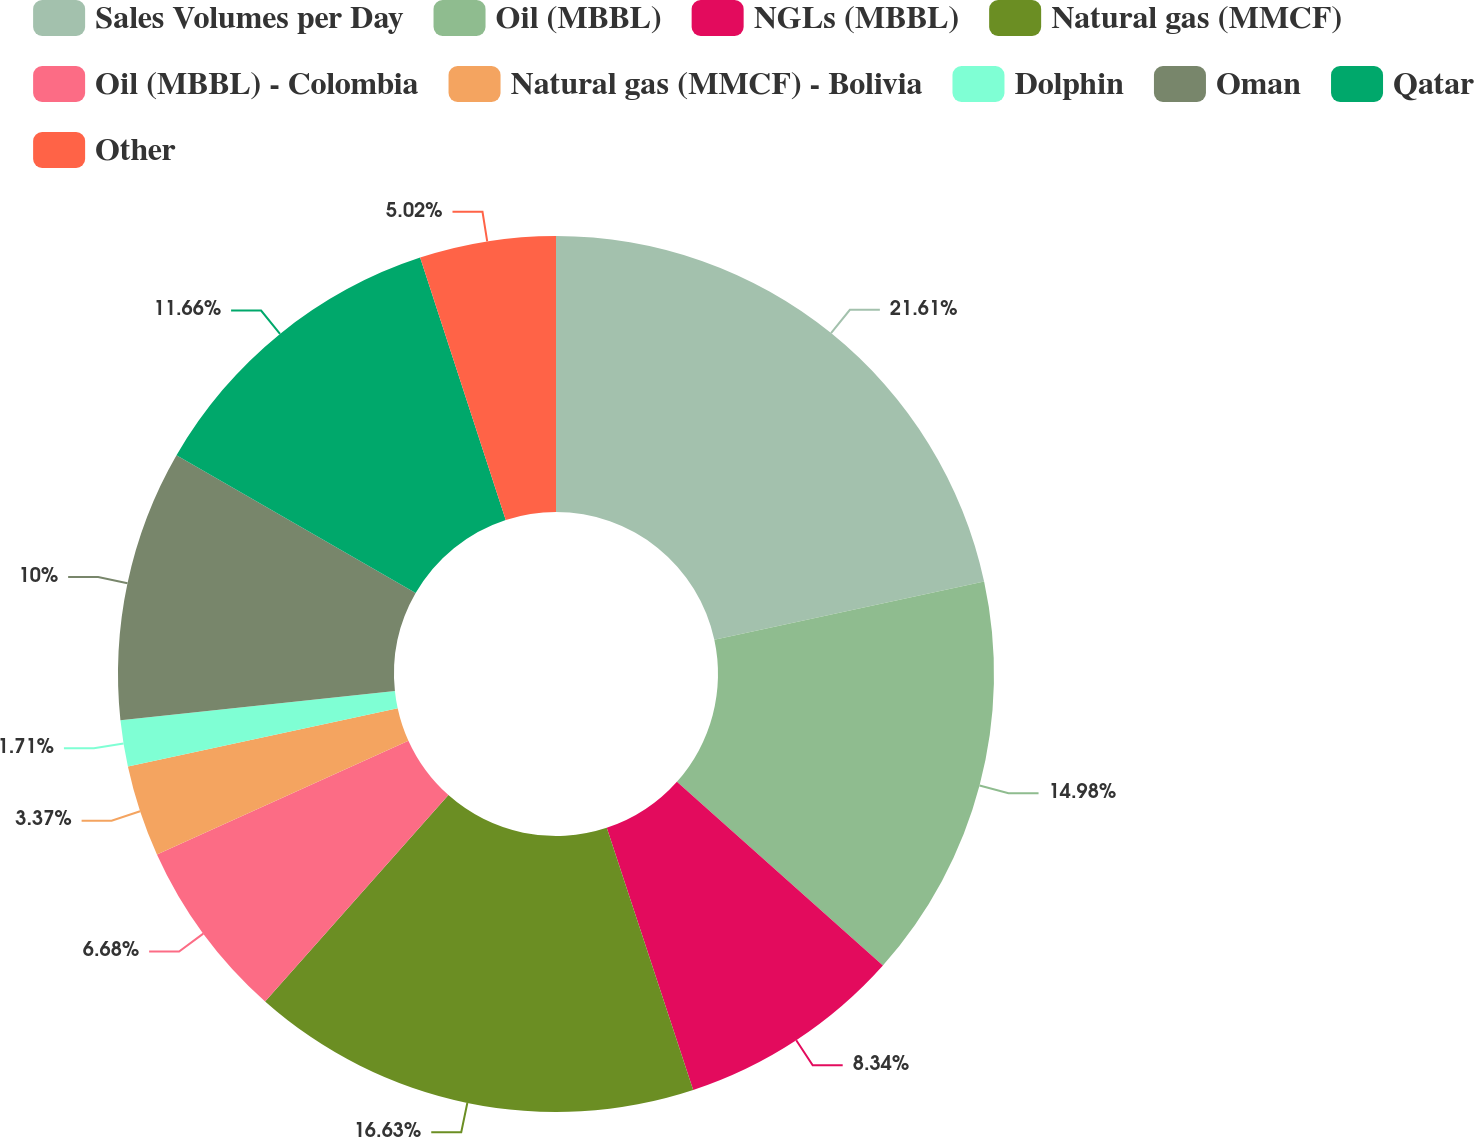Convert chart. <chart><loc_0><loc_0><loc_500><loc_500><pie_chart><fcel>Sales Volumes per Day<fcel>Oil (MBBL)<fcel>NGLs (MBBL)<fcel>Natural gas (MMCF)<fcel>Oil (MBBL) - Colombia<fcel>Natural gas (MMCF) - Bolivia<fcel>Dolphin<fcel>Oman<fcel>Qatar<fcel>Other<nl><fcel>21.61%<fcel>14.98%<fcel>8.34%<fcel>16.63%<fcel>6.68%<fcel>3.37%<fcel>1.71%<fcel>10.0%<fcel>11.66%<fcel>5.02%<nl></chart> 